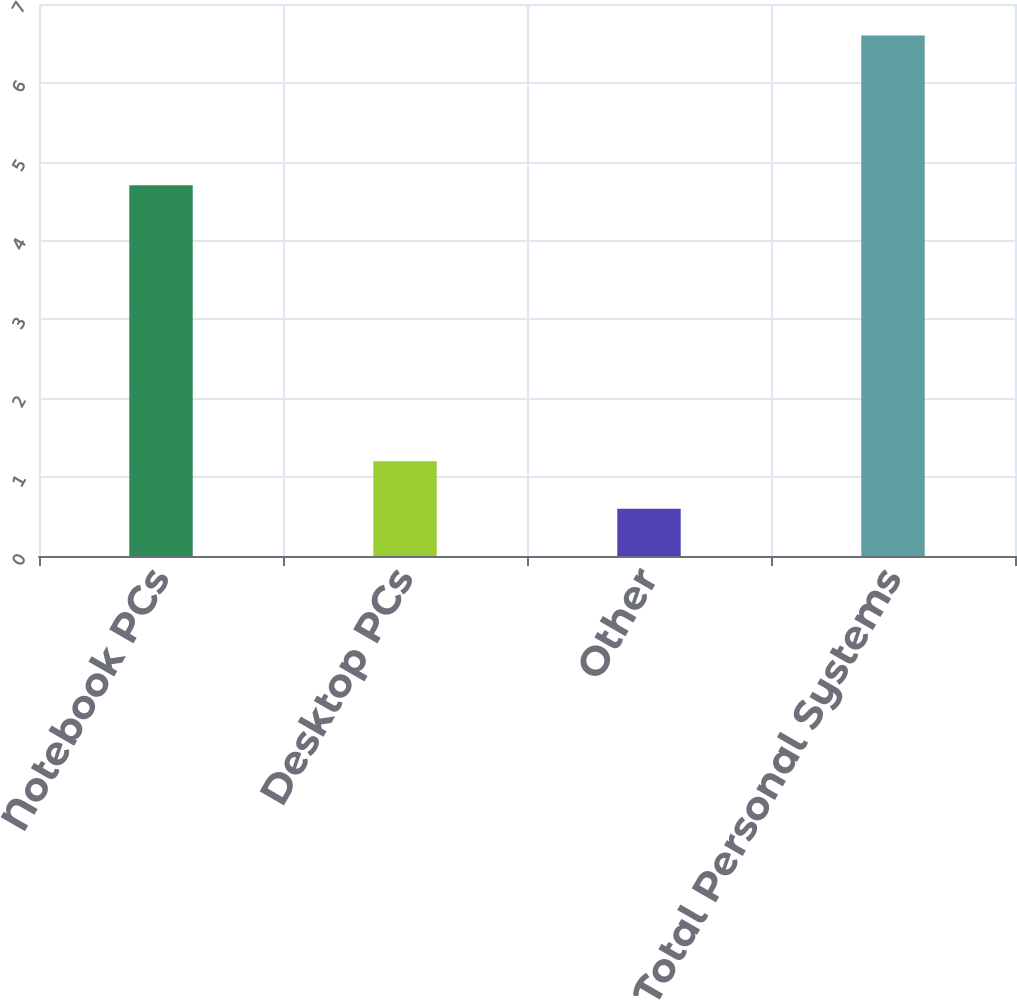<chart> <loc_0><loc_0><loc_500><loc_500><bar_chart><fcel>Notebook PCs<fcel>Desktop PCs<fcel>Other<fcel>Total Personal Systems<nl><fcel>4.7<fcel>1.2<fcel>0.6<fcel>6.6<nl></chart> 